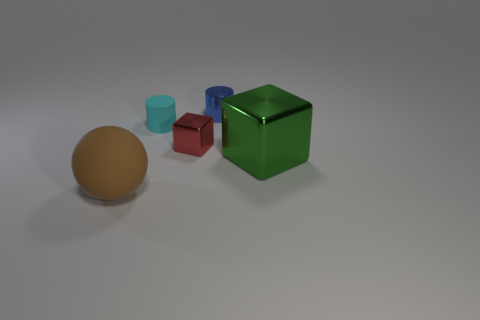Subtract all blue cylinders. How many cylinders are left? 1 Subtract 0 red cylinders. How many objects are left? 5 Subtract all blocks. How many objects are left? 3 Subtract 2 cylinders. How many cylinders are left? 0 Subtract all gray cubes. Subtract all blue cylinders. How many cubes are left? 2 Subtract all purple balls. How many green cubes are left? 1 Subtract all tiny blue cylinders. Subtract all small blue metal objects. How many objects are left? 3 Add 2 green shiny objects. How many green shiny objects are left? 3 Add 1 blue shiny cylinders. How many blue shiny cylinders exist? 2 Add 2 large gray metal cylinders. How many objects exist? 7 